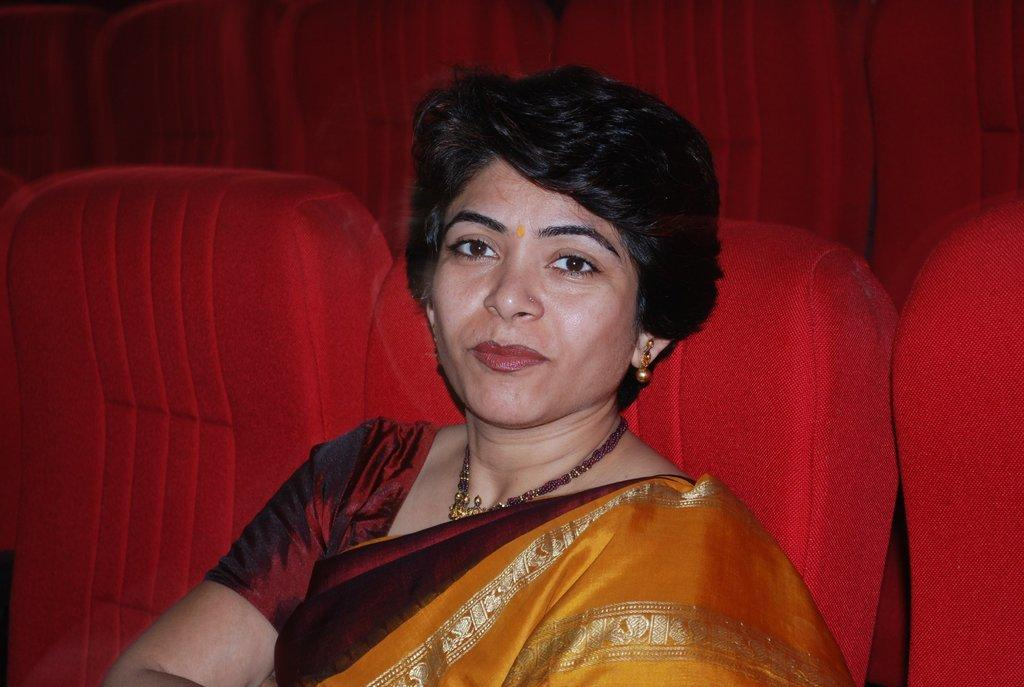Who is present in the image? There is a woman in the image. What is the woman doing in the image? The woman is sitting on a chair. Can you describe the setting of the image? There are chairs visible in the background of the image. How many ants can be seen crawling on the woman's face in the image? There are no ants visible on the woman's face in the image. 